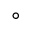Convert formula to latex. <formula><loc_0><loc_0><loc_500><loc_500>^ { \circ }</formula> 